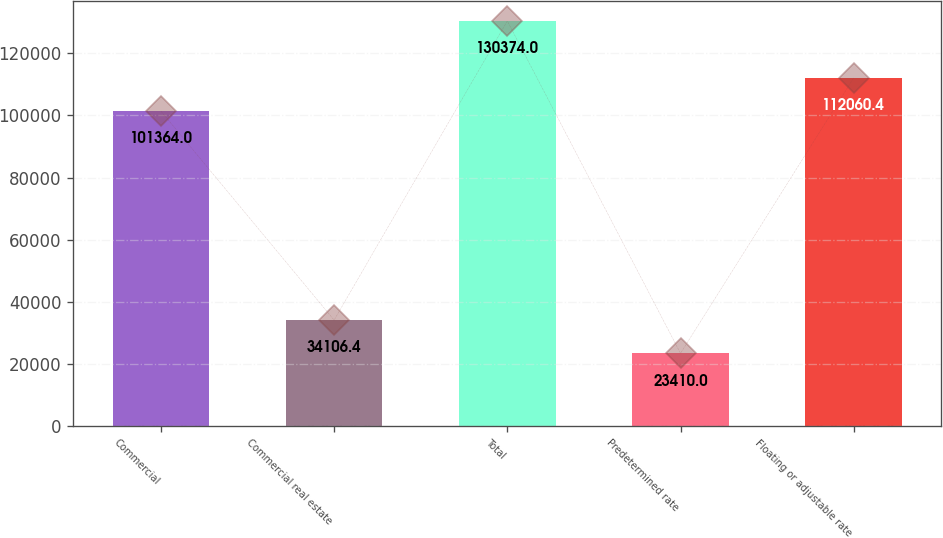Convert chart. <chart><loc_0><loc_0><loc_500><loc_500><bar_chart><fcel>Commercial<fcel>Commercial real estate<fcel>Total<fcel>Predetermined rate<fcel>Floating or adjustable rate<nl><fcel>101364<fcel>34106.4<fcel>130374<fcel>23410<fcel>112060<nl></chart> 